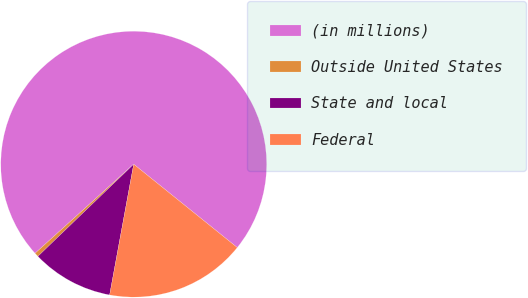Convert chart. <chart><loc_0><loc_0><loc_500><loc_500><pie_chart><fcel>(in millions)<fcel>Outside United States<fcel>State and local<fcel>Federal<nl><fcel>72.48%<fcel>0.5%<fcel>9.91%<fcel>17.11%<nl></chart> 